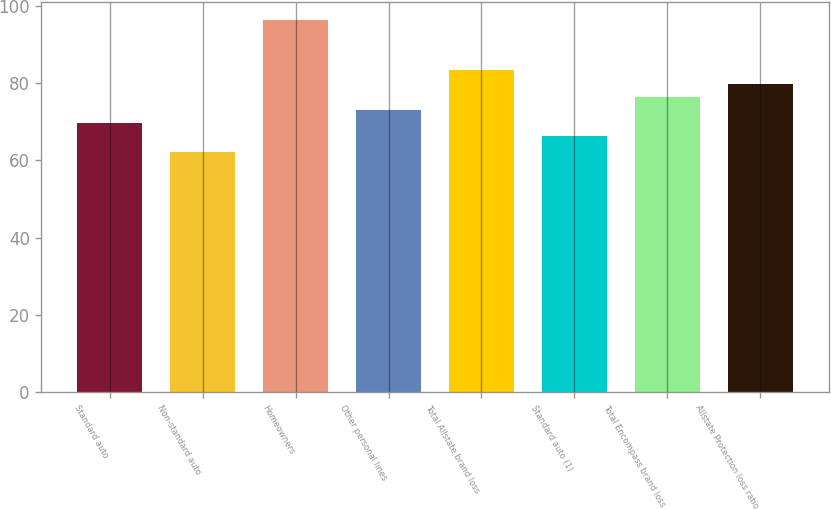Convert chart. <chart><loc_0><loc_0><loc_500><loc_500><bar_chart><fcel>Standard auto<fcel>Non-standard auto<fcel>Homeowners<fcel>Other personal lines<fcel>Total Allstate brand loss<fcel>Standard auto (1)<fcel>Total Encompass brand loss<fcel>Allstate Protection loss ratio<nl><fcel>69.7<fcel>62.3<fcel>96.3<fcel>73.1<fcel>83.3<fcel>66.3<fcel>76.5<fcel>79.9<nl></chart> 